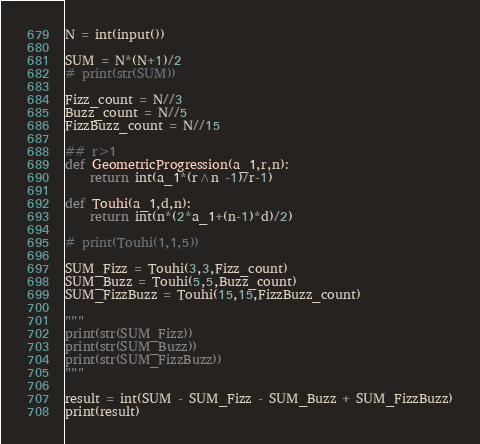<code> <loc_0><loc_0><loc_500><loc_500><_Python_>N = int(input())

SUM = N*(N+1)/2
# print(str(SUM))

Fizz_count = N//3
Buzz_count = N//5
FizzBuzz_count = N//15

## r>1
def GeometricProgression(a_1,r,n):
    return int(a_1*(r^n -1)/r-1)

def Touhi(a_1,d,n):
    return int(n*(2*a_1+(n-1)*d)/2)

# print(Touhi(1,1,5))

SUM_Fizz = Touhi(3,3,Fizz_count)
SUM_Buzz = Touhi(5,5,Buzz_count)
SUM_FizzBuzz = Touhi(15,15,FizzBuzz_count)

"""
print(str(SUM_Fizz))
print(str(SUM_Buzz))
print(str(SUM_FizzBuzz))
"""

result = int(SUM - SUM_Fizz - SUM_Buzz + SUM_FizzBuzz)
print(result)</code> 